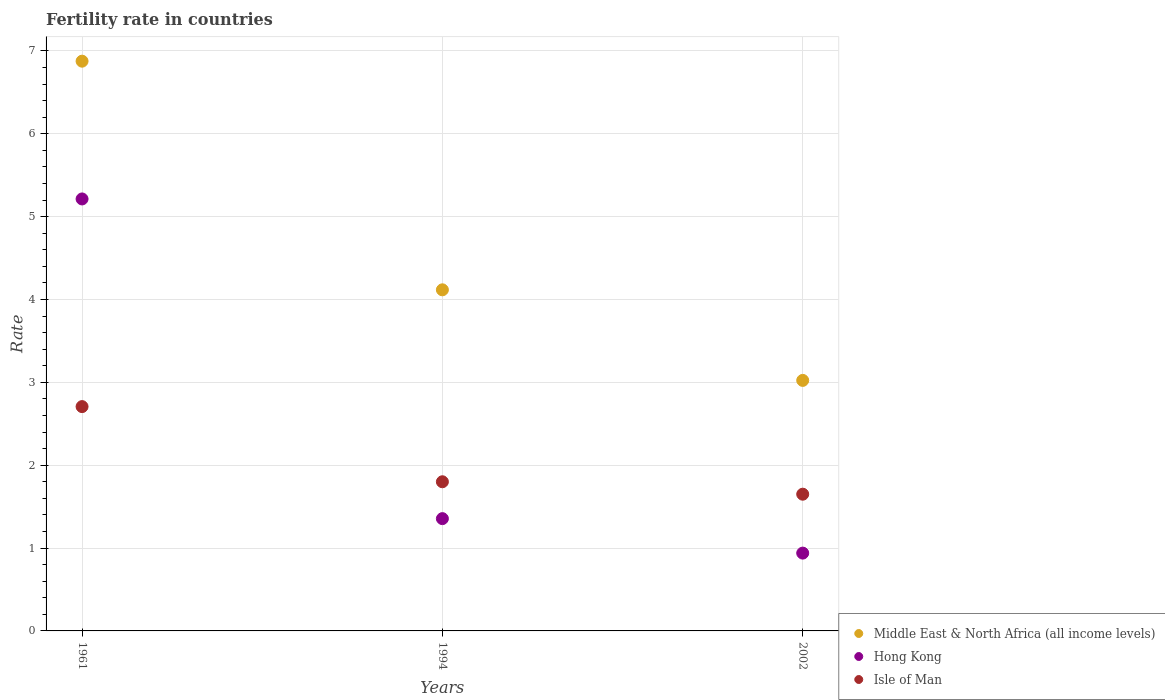What is the fertility rate in Hong Kong in 2002?
Give a very brief answer. 0.94. Across all years, what is the maximum fertility rate in Isle of Man?
Ensure brevity in your answer.  2.71. Across all years, what is the minimum fertility rate in Middle East & North Africa (all income levels)?
Offer a terse response. 3.02. In which year was the fertility rate in Hong Kong maximum?
Provide a succinct answer. 1961. In which year was the fertility rate in Hong Kong minimum?
Your response must be concise. 2002. What is the total fertility rate in Hong Kong in the graph?
Your response must be concise. 7.51. What is the difference between the fertility rate in Middle East & North Africa (all income levels) in 1994 and that in 2002?
Provide a short and direct response. 1.09. What is the difference between the fertility rate in Middle East & North Africa (all income levels) in 2002 and the fertility rate in Hong Kong in 1994?
Give a very brief answer. 1.67. What is the average fertility rate in Hong Kong per year?
Keep it short and to the point. 2.5. In the year 2002, what is the difference between the fertility rate in Isle of Man and fertility rate in Middle East & North Africa (all income levels)?
Ensure brevity in your answer.  -1.37. What is the ratio of the fertility rate in Hong Kong in 1994 to that in 2002?
Your answer should be very brief. 1.44. Is the difference between the fertility rate in Isle of Man in 1961 and 2002 greater than the difference between the fertility rate in Middle East & North Africa (all income levels) in 1961 and 2002?
Provide a short and direct response. No. What is the difference between the highest and the second highest fertility rate in Middle East & North Africa (all income levels)?
Make the answer very short. 2.76. What is the difference between the highest and the lowest fertility rate in Isle of Man?
Keep it short and to the point. 1.06. In how many years, is the fertility rate in Middle East & North Africa (all income levels) greater than the average fertility rate in Middle East & North Africa (all income levels) taken over all years?
Provide a short and direct response. 1. Is it the case that in every year, the sum of the fertility rate in Isle of Man and fertility rate in Middle East & North Africa (all income levels)  is greater than the fertility rate in Hong Kong?
Ensure brevity in your answer.  Yes. Is the fertility rate in Isle of Man strictly less than the fertility rate in Hong Kong over the years?
Your answer should be very brief. No. How many dotlines are there?
Give a very brief answer. 3. How many years are there in the graph?
Make the answer very short. 3. What is the difference between two consecutive major ticks on the Y-axis?
Ensure brevity in your answer.  1. Does the graph contain any zero values?
Ensure brevity in your answer.  No. Where does the legend appear in the graph?
Your answer should be compact. Bottom right. How many legend labels are there?
Give a very brief answer. 3. What is the title of the graph?
Give a very brief answer. Fertility rate in countries. Does "Egypt, Arab Rep." appear as one of the legend labels in the graph?
Offer a terse response. No. What is the label or title of the X-axis?
Provide a short and direct response. Years. What is the label or title of the Y-axis?
Offer a very short reply. Rate. What is the Rate of Middle East & North Africa (all income levels) in 1961?
Your response must be concise. 6.88. What is the Rate of Hong Kong in 1961?
Make the answer very short. 5.21. What is the Rate of Isle of Man in 1961?
Give a very brief answer. 2.71. What is the Rate of Middle East & North Africa (all income levels) in 1994?
Your answer should be very brief. 4.12. What is the Rate in Hong Kong in 1994?
Keep it short and to the point. 1.35. What is the Rate in Middle East & North Africa (all income levels) in 2002?
Give a very brief answer. 3.02. What is the Rate in Hong Kong in 2002?
Provide a short and direct response. 0.94. What is the Rate in Isle of Man in 2002?
Provide a succinct answer. 1.65. Across all years, what is the maximum Rate in Middle East & North Africa (all income levels)?
Provide a short and direct response. 6.88. Across all years, what is the maximum Rate of Hong Kong?
Your answer should be compact. 5.21. Across all years, what is the maximum Rate in Isle of Man?
Your answer should be very brief. 2.71. Across all years, what is the minimum Rate in Middle East & North Africa (all income levels)?
Your answer should be compact. 3.02. Across all years, what is the minimum Rate in Hong Kong?
Your response must be concise. 0.94. Across all years, what is the minimum Rate in Isle of Man?
Your answer should be compact. 1.65. What is the total Rate in Middle East & North Africa (all income levels) in the graph?
Offer a very short reply. 14.02. What is the total Rate of Hong Kong in the graph?
Provide a succinct answer. 7.51. What is the total Rate in Isle of Man in the graph?
Offer a very short reply. 6.16. What is the difference between the Rate of Middle East & North Africa (all income levels) in 1961 and that in 1994?
Your answer should be compact. 2.76. What is the difference between the Rate of Hong Kong in 1961 and that in 1994?
Ensure brevity in your answer.  3.86. What is the difference between the Rate of Isle of Man in 1961 and that in 1994?
Keep it short and to the point. 0.91. What is the difference between the Rate of Middle East & North Africa (all income levels) in 1961 and that in 2002?
Ensure brevity in your answer.  3.85. What is the difference between the Rate in Hong Kong in 1961 and that in 2002?
Offer a very short reply. 4.27. What is the difference between the Rate of Isle of Man in 1961 and that in 2002?
Offer a terse response. 1.06. What is the difference between the Rate of Middle East & North Africa (all income levels) in 1994 and that in 2002?
Make the answer very short. 1.09. What is the difference between the Rate of Hong Kong in 1994 and that in 2002?
Your answer should be compact. 0.42. What is the difference between the Rate in Middle East & North Africa (all income levels) in 1961 and the Rate in Hong Kong in 1994?
Provide a short and direct response. 5.52. What is the difference between the Rate in Middle East & North Africa (all income levels) in 1961 and the Rate in Isle of Man in 1994?
Provide a short and direct response. 5.08. What is the difference between the Rate of Hong Kong in 1961 and the Rate of Isle of Man in 1994?
Your answer should be very brief. 3.41. What is the difference between the Rate of Middle East & North Africa (all income levels) in 1961 and the Rate of Hong Kong in 2002?
Offer a terse response. 5.94. What is the difference between the Rate of Middle East & North Africa (all income levels) in 1961 and the Rate of Isle of Man in 2002?
Make the answer very short. 5.23. What is the difference between the Rate of Hong Kong in 1961 and the Rate of Isle of Man in 2002?
Keep it short and to the point. 3.56. What is the difference between the Rate of Middle East & North Africa (all income levels) in 1994 and the Rate of Hong Kong in 2002?
Make the answer very short. 3.18. What is the difference between the Rate in Middle East & North Africa (all income levels) in 1994 and the Rate in Isle of Man in 2002?
Ensure brevity in your answer.  2.47. What is the difference between the Rate of Hong Kong in 1994 and the Rate of Isle of Man in 2002?
Give a very brief answer. -0.29. What is the average Rate in Middle East & North Africa (all income levels) per year?
Your answer should be very brief. 4.67. What is the average Rate in Hong Kong per year?
Provide a succinct answer. 2.5. What is the average Rate of Isle of Man per year?
Your answer should be very brief. 2.05. In the year 1961, what is the difference between the Rate of Middle East & North Africa (all income levels) and Rate of Hong Kong?
Give a very brief answer. 1.66. In the year 1961, what is the difference between the Rate in Middle East & North Africa (all income levels) and Rate in Isle of Man?
Make the answer very short. 4.17. In the year 1961, what is the difference between the Rate of Hong Kong and Rate of Isle of Man?
Provide a succinct answer. 2.51. In the year 1994, what is the difference between the Rate in Middle East & North Africa (all income levels) and Rate in Hong Kong?
Ensure brevity in your answer.  2.76. In the year 1994, what is the difference between the Rate of Middle East & North Africa (all income levels) and Rate of Isle of Man?
Make the answer very short. 2.32. In the year 1994, what is the difference between the Rate in Hong Kong and Rate in Isle of Man?
Keep it short and to the point. -0.45. In the year 2002, what is the difference between the Rate in Middle East & North Africa (all income levels) and Rate in Hong Kong?
Make the answer very short. 2.08. In the year 2002, what is the difference between the Rate of Middle East & North Africa (all income levels) and Rate of Isle of Man?
Offer a very short reply. 1.37. In the year 2002, what is the difference between the Rate of Hong Kong and Rate of Isle of Man?
Provide a short and direct response. -0.71. What is the ratio of the Rate of Middle East & North Africa (all income levels) in 1961 to that in 1994?
Offer a terse response. 1.67. What is the ratio of the Rate of Hong Kong in 1961 to that in 1994?
Offer a very short reply. 3.85. What is the ratio of the Rate of Isle of Man in 1961 to that in 1994?
Your response must be concise. 1.5. What is the ratio of the Rate in Middle East & North Africa (all income levels) in 1961 to that in 2002?
Make the answer very short. 2.27. What is the ratio of the Rate in Hong Kong in 1961 to that in 2002?
Your answer should be compact. 5.55. What is the ratio of the Rate in Isle of Man in 1961 to that in 2002?
Your response must be concise. 1.64. What is the ratio of the Rate in Middle East & North Africa (all income levels) in 1994 to that in 2002?
Keep it short and to the point. 1.36. What is the ratio of the Rate of Hong Kong in 1994 to that in 2002?
Keep it short and to the point. 1.44. What is the ratio of the Rate in Isle of Man in 1994 to that in 2002?
Offer a terse response. 1.09. What is the difference between the highest and the second highest Rate of Middle East & North Africa (all income levels)?
Provide a short and direct response. 2.76. What is the difference between the highest and the second highest Rate of Hong Kong?
Make the answer very short. 3.86. What is the difference between the highest and the second highest Rate in Isle of Man?
Provide a short and direct response. 0.91. What is the difference between the highest and the lowest Rate in Middle East & North Africa (all income levels)?
Your answer should be compact. 3.85. What is the difference between the highest and the lowest Rate of Hong Kong?
Your response must be concise. 4.27. What is the difference between the highest and the lowest Rate of Isle of Man?
Offer a very short reply. 1.06. 